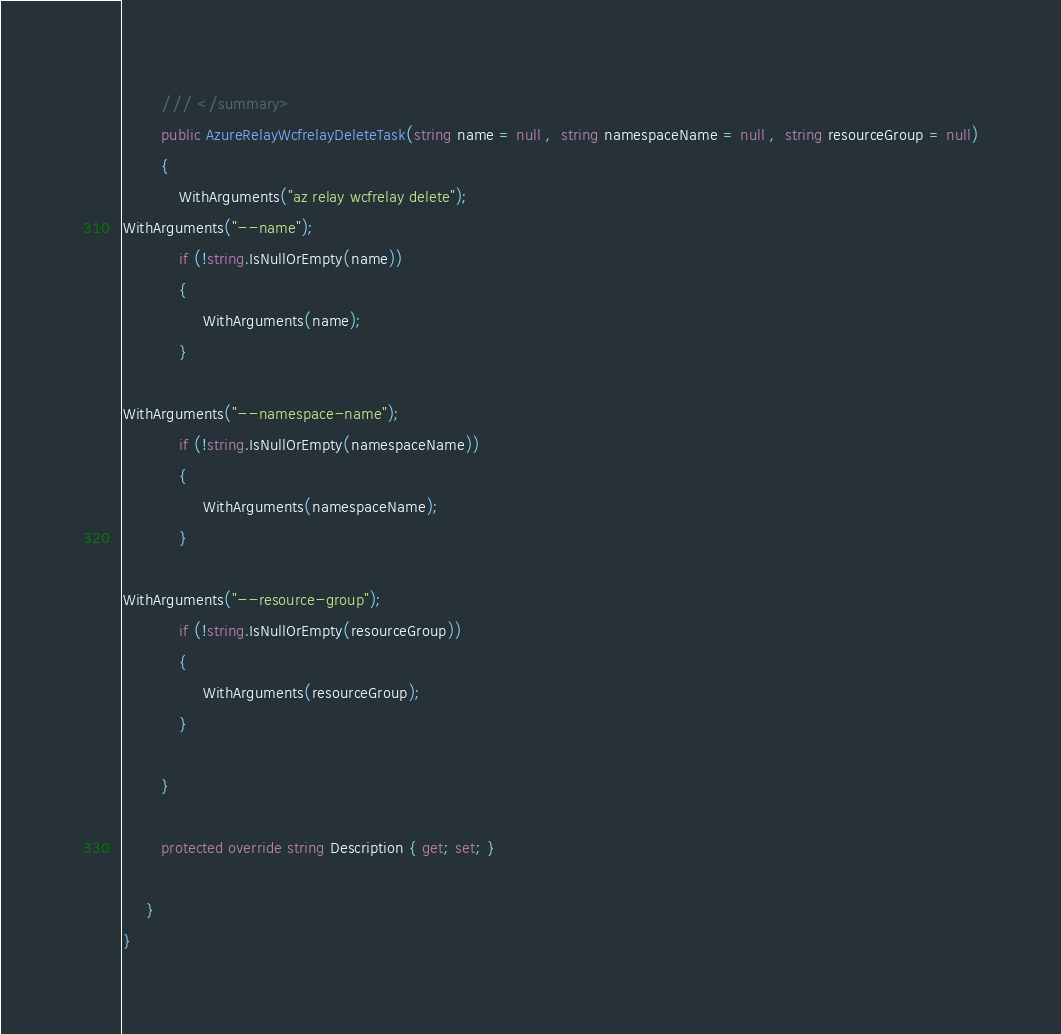<code> <loc_0><loc_0><loc_500><loc_500><_C#_>        /// </summary>
        public AzureRelayWcfrelayDeleteTask(string name = null ,  string namespaceName = null ,  string resourceGroup = null)
        {
            WithArguments("az relay wcfrelay delete");
WithArguments("--name");
            if (!string.IsNullOrEmpty(name))
            {
                 WithArguments(name);
            }

WithArguments("--namespace-name");
            if (!string.IsNullOrEmpty(namespaceName))
            {
                 WithArguments(namespaceName);
            }

WithArguments("--resource-group");
            if (!string.IsNullOrEmpty(resourceGroup))
            {
                 WithArguments(resourceGroup);
            }

        }

        protected override string Description { get; set; }
        
     }
}
</code> 